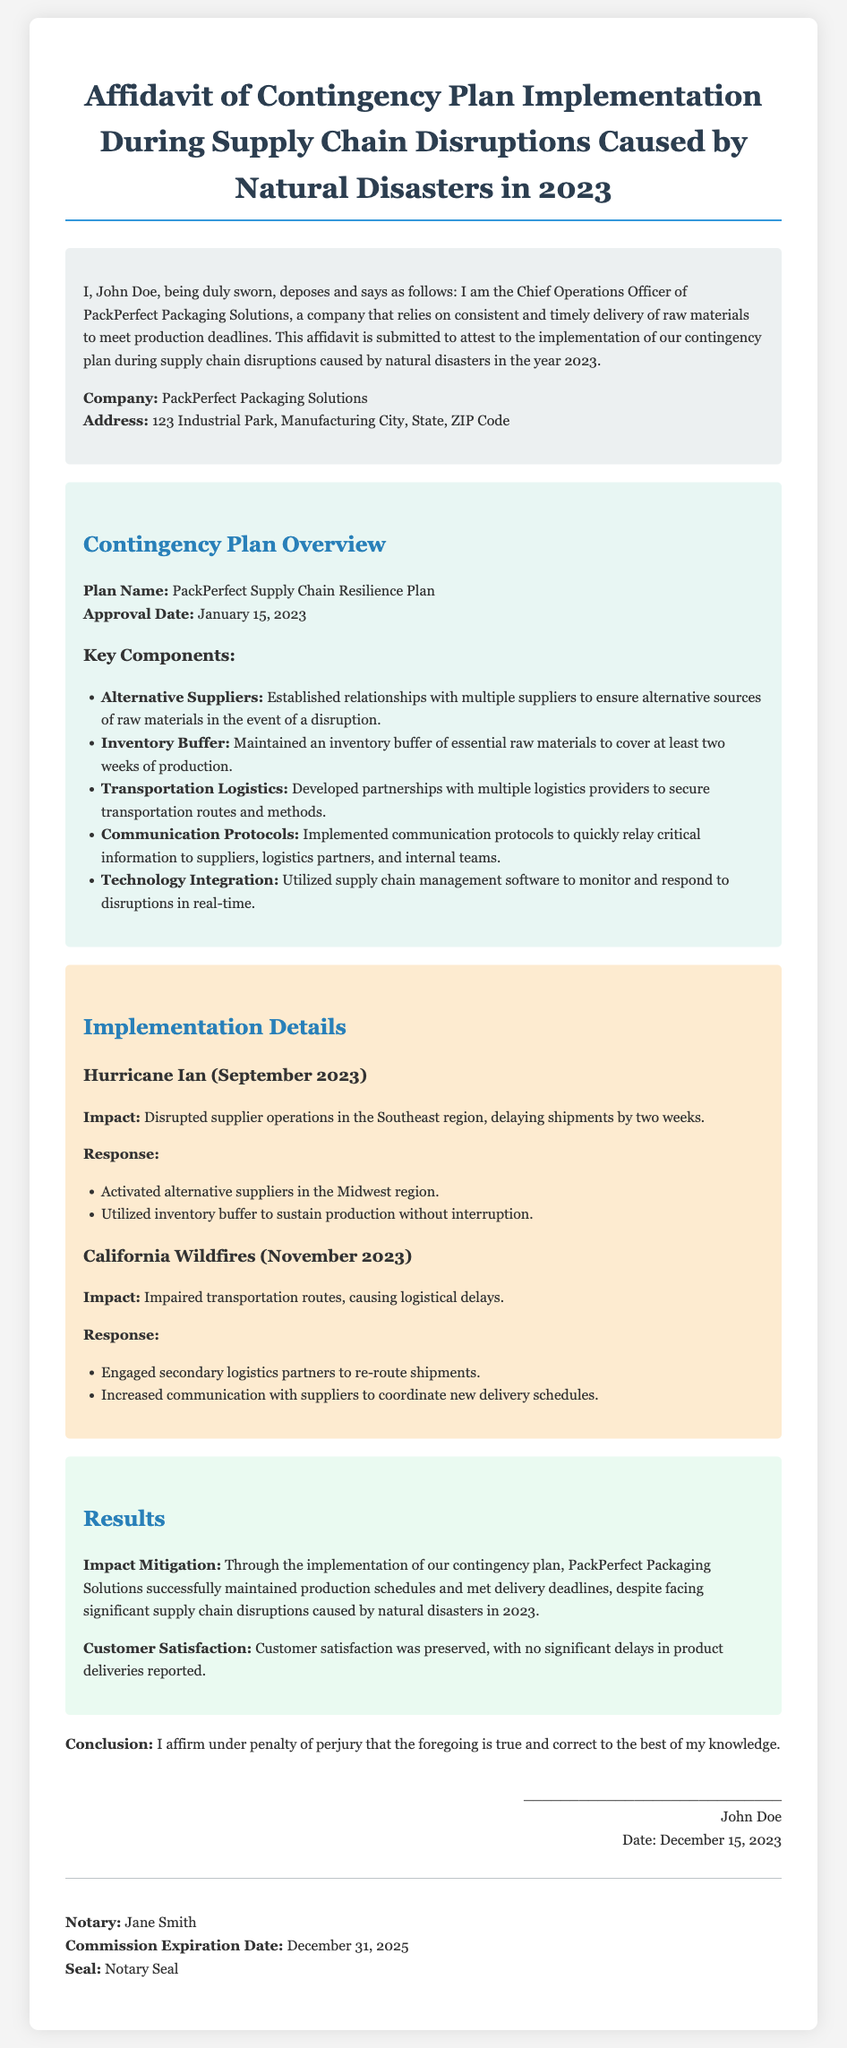What is the name of the affiant? The affiant is identified as John Doe in the document.
Answer: John Doe What is the company name? The company associated with the affiant is PackPerfect Packaging Solutions.
Answer: PackPerfect Packaging Solutions When was the contingency plan approved? The approval date of the contingency plan is specified in the document.
Answer: January 15, 2023 What event caused a two-week shipment delay in September 2023? The document states that Hurricane Ian disrupted supplier operations, causing delays.
Answer: Hurricane Ian What is maintained as an inventory buffer? The document mentions that an inventory buffer of essential raw materials is maintained.
Answer: Essential raw materials What did PackPerfect use to sustain production during the hurricane disruption? The response section indicates that the inventory buffer was utilized to sustain production.
Answer: Inventory buffer How many weeks can the inventory buffer cover? The document explicitly states that the buffer can cover at least two weeks of production.
Answer: Two weeks What was the impact of the California wildfires on logistics? The document describes that the wildfires impaired transportation routes, leading to delays.
Answer: Impaired transportation routes What was the conclusion of the affidavit regarding the implementation? The conclusion reaffirms that the affiant believes the information is true and correct.
Answer: True and correct 